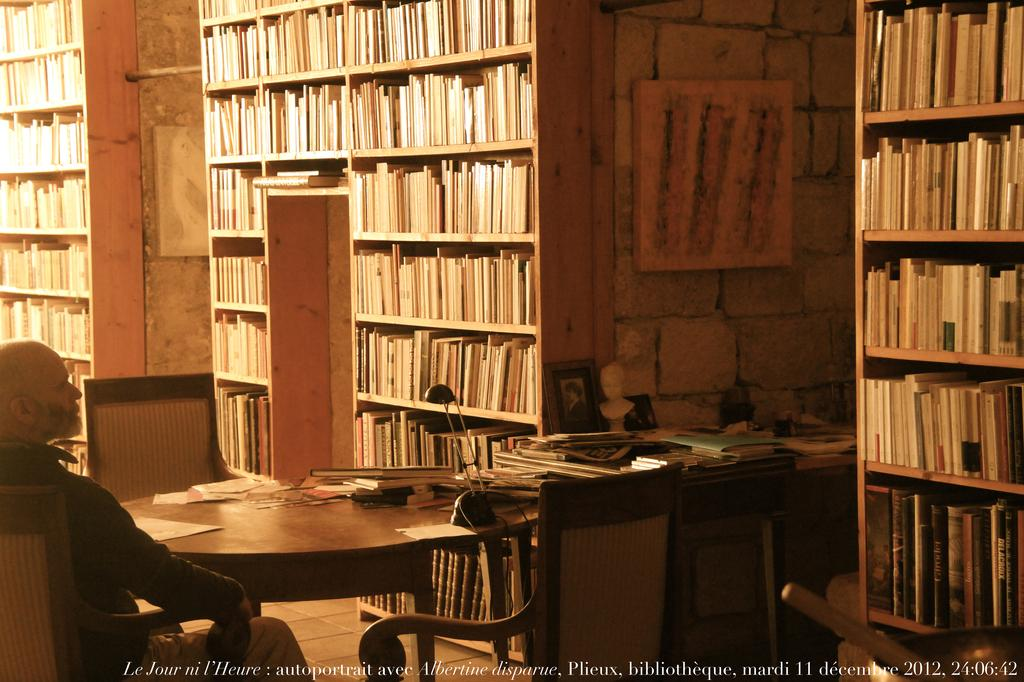<image>
Render a clear and concise summary of the photo. man sitting at table in a library in 2012 